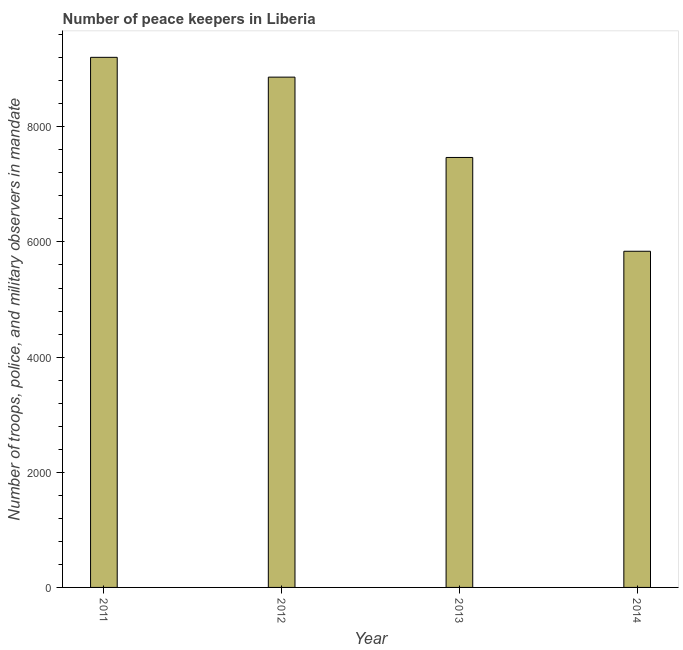What is the title of the graph?
Keep it short and to the point. Number of peace keepers in Liberia. What is the label or title of the Y-axis?
Keep it short and to the point. Number of troops, police, and military observers in mandate. What is the number of peace keepers in 2012?
Your response must be concise. 8862. Across all years, what is the maximum number of peace keepers?
Make the answer very short. 9206. Across all years, what is the minimum number of peace keepers?
Your answer should be very brief. 5838. In which year was the number of peace keepers maximum?
Make the answer very short. 2011. What is the sum of the number of peace keepers?
Keep it short and to the point. 3.14e+04. What is the difference between the number of peace keepers in 2012 and 2013?
Offer a terse response. 1395. What is the average number of peace keepers per year?
Provide a short and direct response. 7843. What is the median number of peace keepers?
Your answer should be compact. 8164.5. Do a majority of the years between 2011 and 2013 (inclusive) have number of peace keepers greater than 7200 ?
Your response must be concise. Yes. What is the ratio of the number of peace keepers in 2011 to that in 2014?
Your answer should be very brief. 1.58. Is the number of peace keepers in 2012 less than that in 2014?
Provide a short and direct response. No. What is the difference between the highest and the second highest number of peace keepers?
Your answer should be compact. 344. What is the difference between the highest and the lowest number of peace keepers?
Offer a very short reply. 3368. What is the difference between two consecutive major ticks on the Y-axis?
Offer a terse response. 2000. Are the values on the major ticks of Y-axis written in scientific E-notation?
Ensure brevity in your answer.  No. What is the Number of troops, police, and military observers in mandate of 2011?
Offer a terse response. 9206. What is the Number of troops, police, and military observers in mandate of 2012?
Make the answer very short. 8862. What is the Number of troops, police, and military observers in mandate in 2013?
Offer a very short reply. 7467. What is the Number of troops, police, and military observers in mandate of 2014?
Provide a succinct answer. 5838. What is the difference between the Number of troops, police, and military observers in mandate in 2011 and 2012?
Make the answer very short. 344. What is the difference between the Number of troops, police, and military observers in mandate in 2011 and 2013?
Ensure brevity in your answer.  1739. What is the difference between the Number of troops, police, and military observers in mandate in 2011 and 2014?
Provide a succinct answer. 3368. What is the difference between the Number of troops, police, and military observers in mandate in 2012 and 2013?
Offer a very short reply. 1395. What is the difference between the Number of troops, police, and military observers in mandate in 2012 and 2014?
Make the answer very short. 3024. What is the difference between the Number of troops, police, and military observers in mandate in 2013 and 2014?
Provide a succinct answer. 1629. What is the ratio of the Number of troops, police, and military observers in mandate in 2011 to that in 2012?
Provide a succinct answer. 1.04. What is the ratio of the Number of troops, police, and military observers in mandate in 2011 to that in 2013?
Your answer should be very brief. 1.23. What is the ratio of the Number of troops, police, and military observers in mandate in 2011 to that in 2014?
Keep it short and to the point. 1.58. What is the ratio of the Number of troops, police, and military observers in mandate in 2012 to that in 2013?
Provide a succinct answer. 1.19. What is the ratio of the Number of troops, police, and military observers in mandate in 2012 to that in 2014?
Ensure brevity in your answer.  1.52. What is the ratio of the Number of troops, police, and military observers in mandate in 2013 to that in 2014?
Offer a terse response. 1.28. 